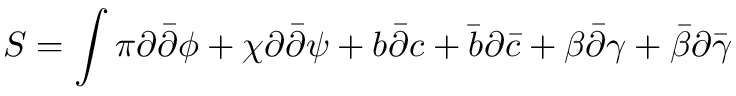<formula> <loc_0><loc_0><loc_500><loc_500>S = \int \pi \partial { \bar { \partial } } \phi + \chi \partial { \bar { \partial } } \psi + b { \bar { \partial } } c + { \bar { b } } \partial { \bar { c } } + \beta { \bar { \partial } } \gamma + { \bar { \beta } } \partial { \bar { \gamma } }</formula> 